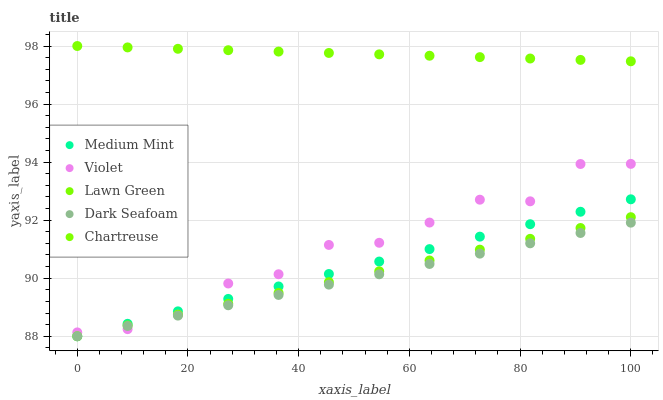Does Dark Seafoam have the minimum area under the curve?
Answer yes or no. Yes. Does Chartreuse have the maximum area under the curve?
Answer yes or no. Yes. Does Lawn Green have the minimum area under the curve?
Answer yes or no. No. Does Lawn Green have the maximum area under the curve?
Answer yes or no. No. Is Medium Mint the smoothest?
Answer yes or no. Yes. Is Violet the roughest?
Answer yes or no. Yes. Is Lawn Green the smoothest?
Answer yes or no. No. Is Lawn Green the roughest?
Answer yes or no. No. Does Medium Mint have the lowest value?
Answer yes or no. Yes. Does Chartreuse have the lowest value?
Answer yes or no. No. Does Chartreuse have the highest value?
Answer yes or no. Yes. Does Lawn Green have the highest value?
Answer yes or no. No. Is Medium Mint less than Chartreuse?
Answer yes or no. Yes. Is Chartreuse greater than Lawn Green?
Answer yes or no. Yes. Does Medium Mint intersect Violet?
Answer yes or no. Yes. Is Medium Mint less than Violet?
Answer yes or no. No. Is Medium Mint greater than Violet?
Answer yes or no. No. Does Medium Mint intersect Chartreuse?
Answer yes or no. No. 